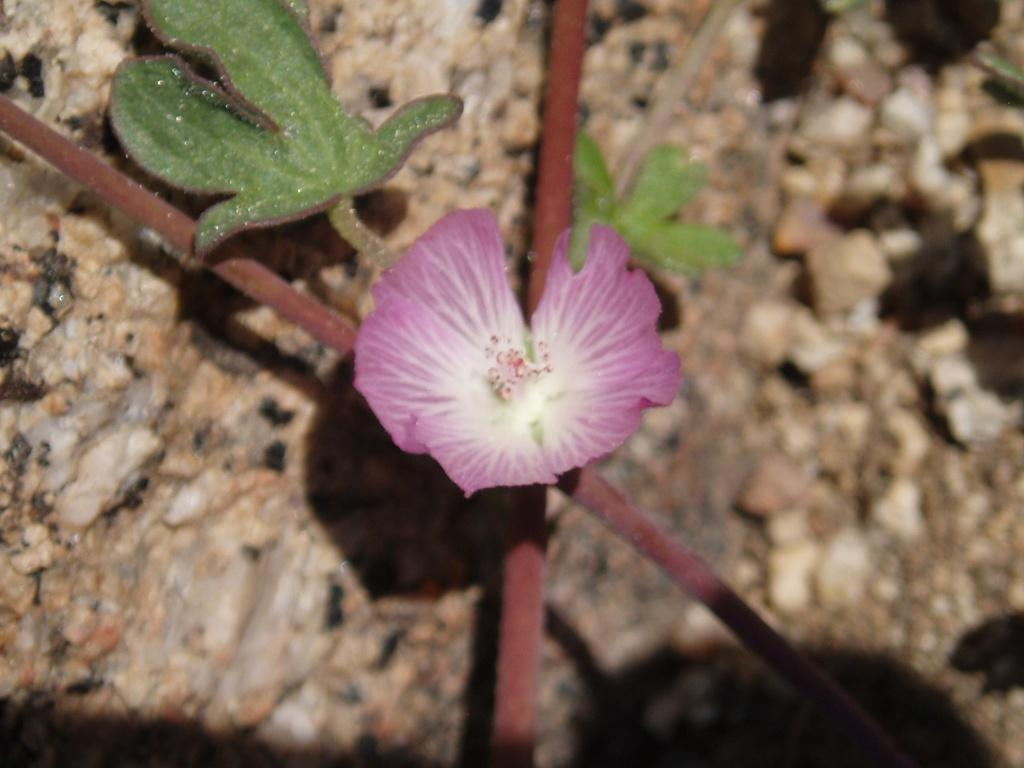What type of plant is visible in the image? There is a flower in the image. What parts of the plant can be seen in the image? There are leaves and stems visible in the image. What can be seen in the background of the image? There are stones in the background of the image. What type of comb is being used to groom the flower in the image? There is no comb present in the image, and flowers do not require grooming. 